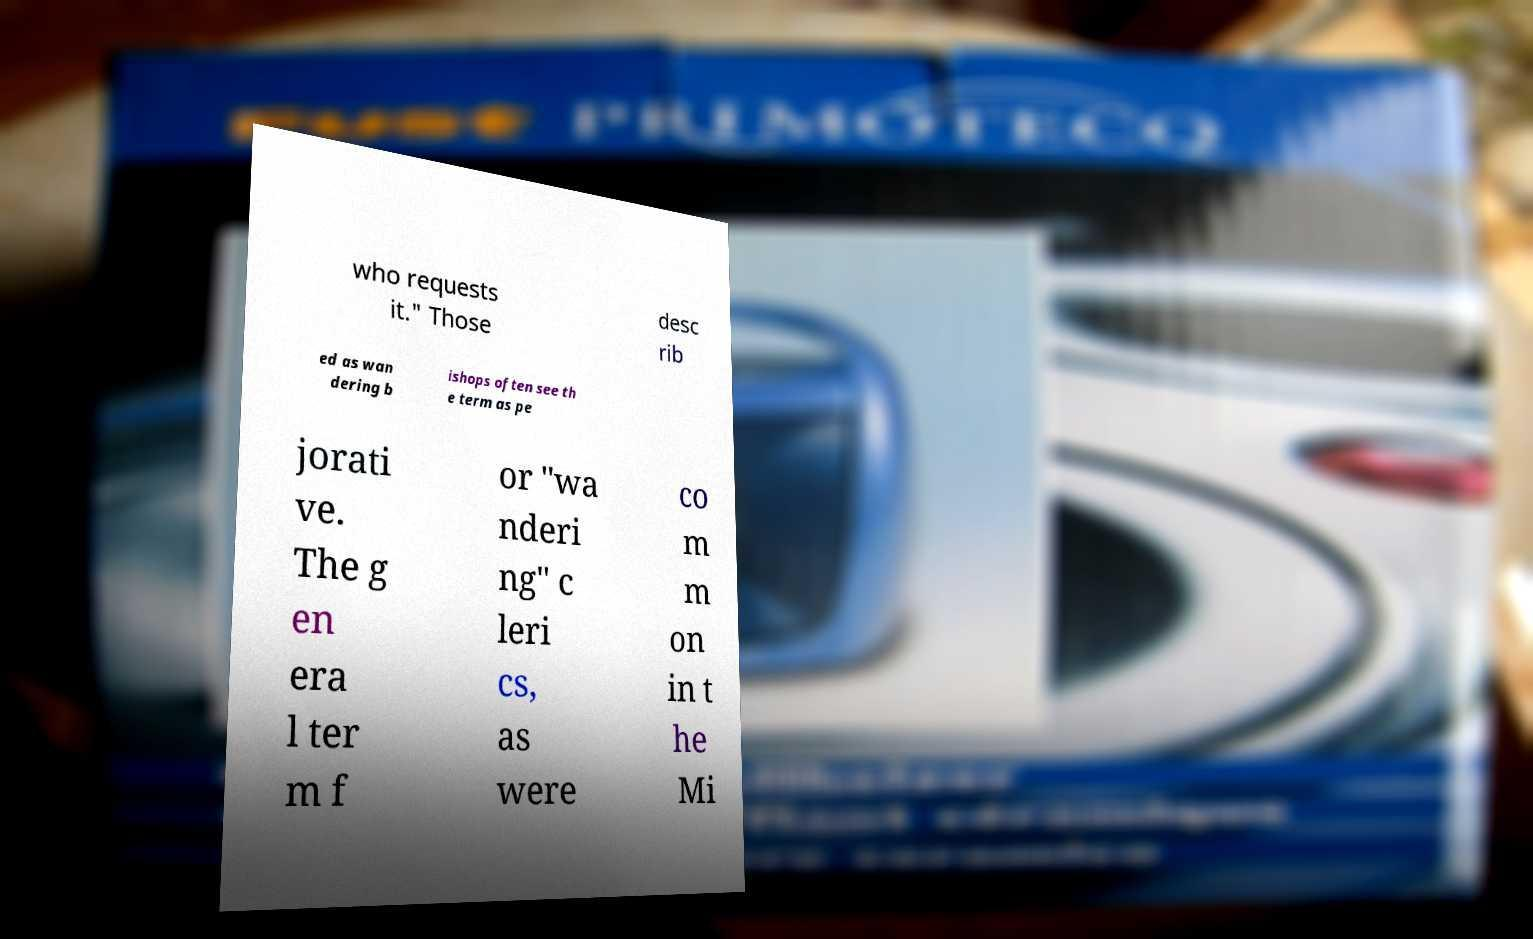Can you accurately transcribe the text from the provided image for me? who requests it." Those desc rib ed as wan dering b ishops often see th e term as pe jorati ve. The g en era l ter m f or "wa nderi ng" c leri cs, as were co m m on in t he Mi 